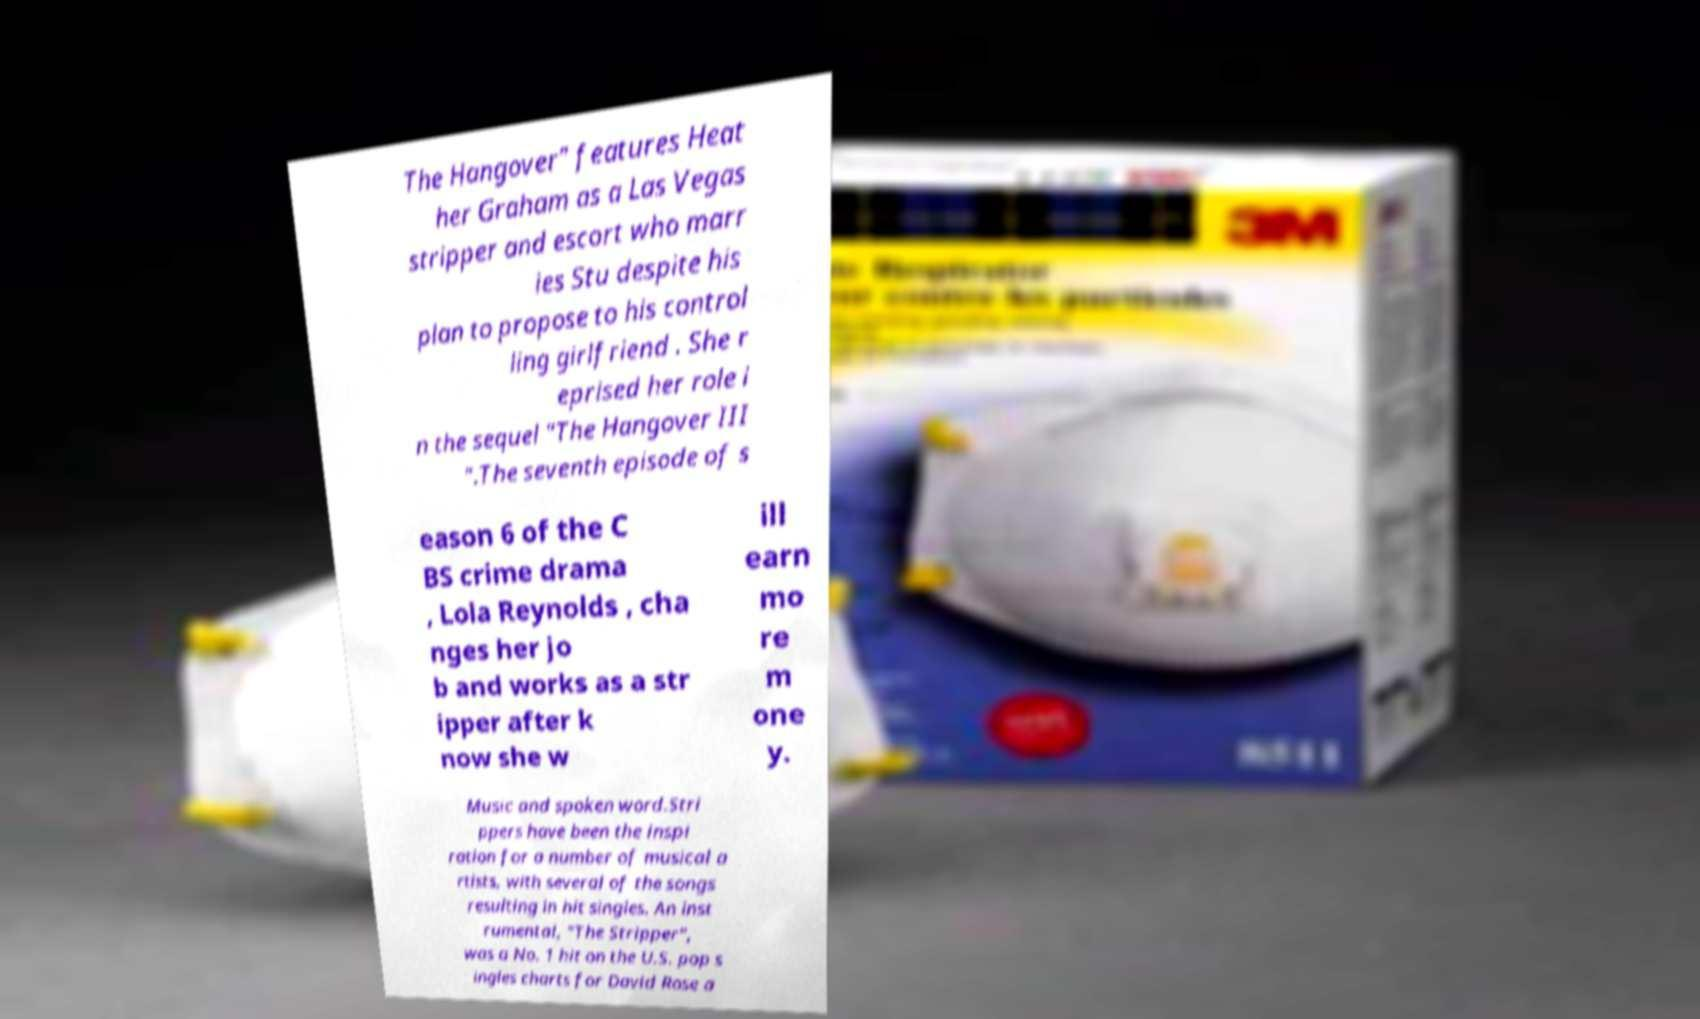Can you read and provide the text displayed in the image?This photo seems to have some interesting text. Can you extract and type it out for me? The Hangover" features Heat her Graham as a Las Vegas stripper and escort who marr ies Stu despite his plan to propose to his control ling girlfriend . She r eprised her role i n the sequel "The Hangover III ".The seventh episode of s eason 6 of the C BS crime drama , Lola Reynolds , cha nges her jo b and works as a str ipper after k now she w ill earn mo re m one y. Music and spoken word.Stri ppers have been the inspi ration for a number of musical a rtists, with several of the songs resulting in hit singles. An inst rumental, "The Stripper", was a No. 1 hit on the U.S. pop s ingles charts for David Rose a 